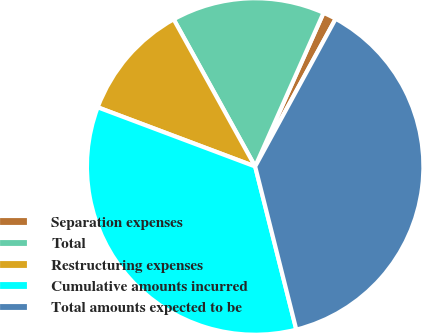Convert chart. <chart><loc_0><loc_0><loc_500><loc_500><pie_chart><fcel>Separation expenses<fcel>Total<fcel>Restructuring expenses<fcel>Cumulative amounts incurred<fcel>Total amounts expected to be<nl><fcel>1.28%<fcel>14.71%<fcel>11.23%<fcel>34.66%<fcel>38.13%<nl></chart> 